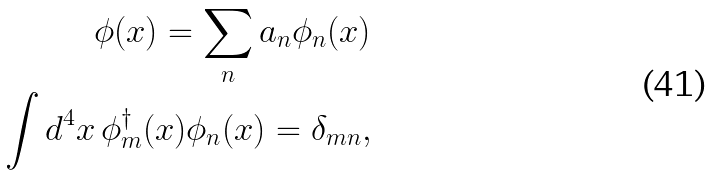Convert formula to latex. <formula><loc_0><loc_0><loc_500><loc_500>\phi ( x ) = \sum _ { n } a _ { n } \phi _ { n } ( x ) \\ \int d ^ { 4 } x \, \phi ^ { \dagger } _ { m } ( x ) \phi _ { n } ( x ) = \delta _ { m n } ,</formula> 